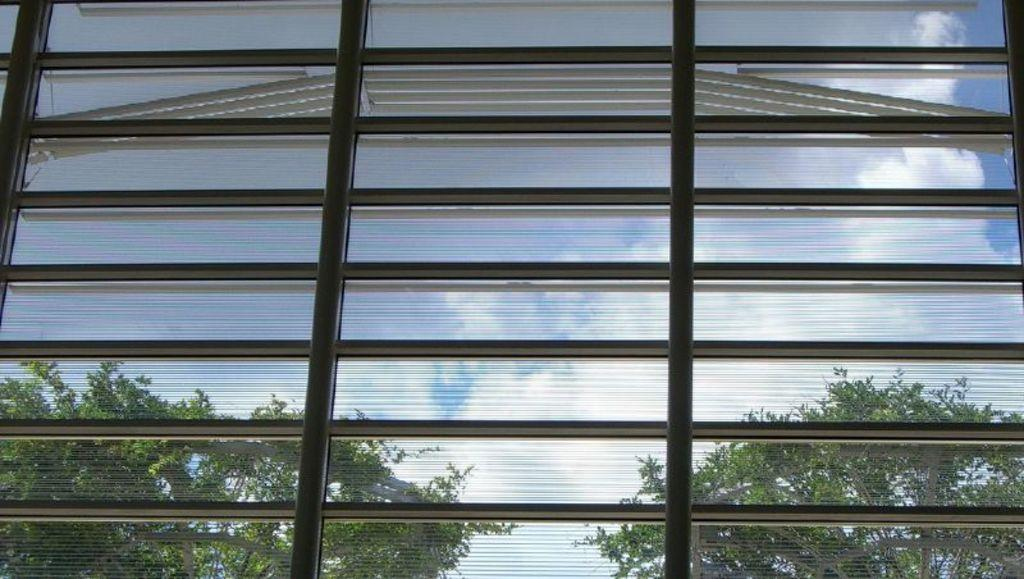What type of structure is present in the image? There is a glass window in the image. What can be seen through the window? Trees, clouds, and the sky are visible through the window. Where can the berry be found in the image? There is no berry present in the image. What type of place is depicted in the image? The image does not depict a specific place; it shows a window with a view of trees, clouds, and the sky. 